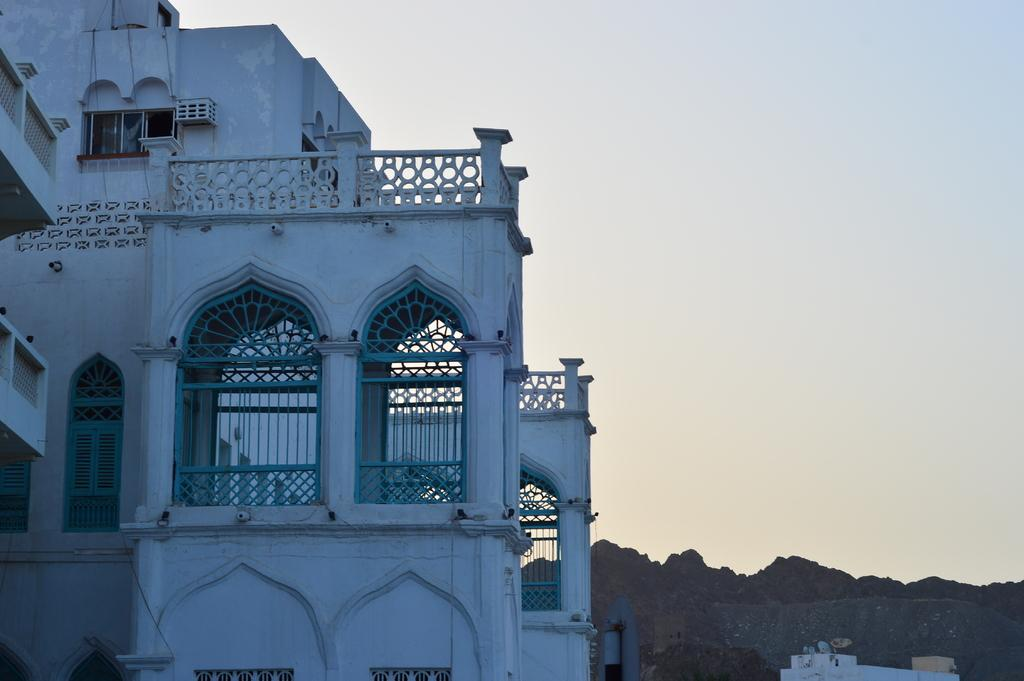What is the main subject in the foreground of the image? There is a building in the foreground of the image. What can be seen in the background of the image? Mountains are visible behind the building. What type of blood is visible on the playground in the image? There is no playground or blood present in the image; it features a building and mountains. 